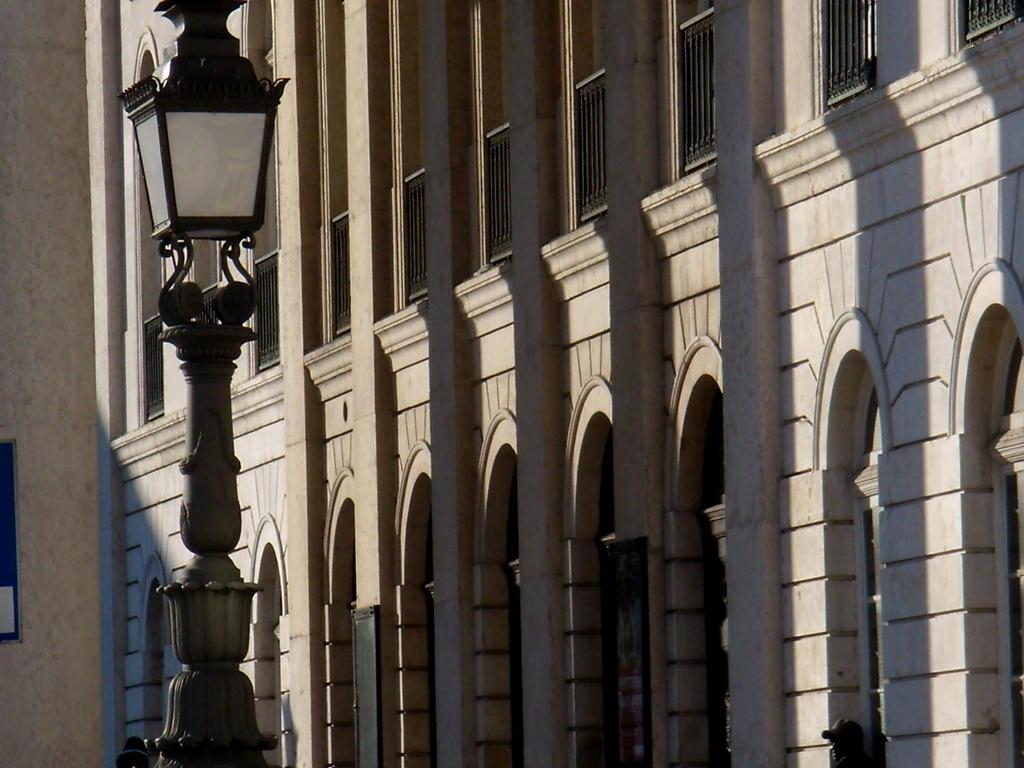What type of structure is visible in the image? There is a building in the image. Can you describe any other elements in the image? There is a person and a light pole visible in the image. Are there any other objects present in the image? Yes, there are some unspecified objects in the image. What is the distribution of milk in the image? There is no milk present in the image, so it is not possible to determine its distribution. 